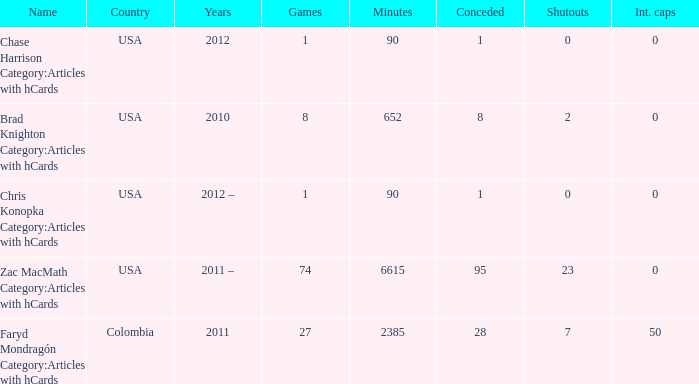When chase harrison category: articles containing hcards is the title, what is the year? 2012.0. 